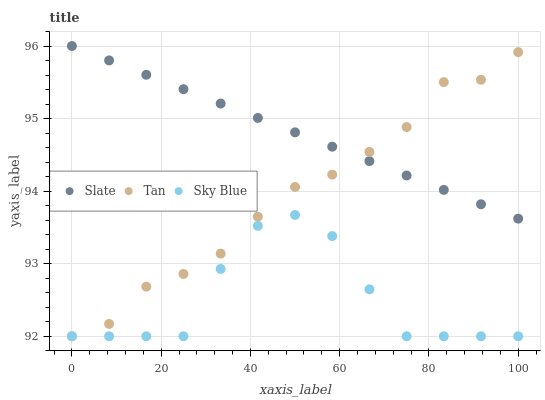Does Sky Blue have the minimum area under the curve?
Answer yes or no. Yes. Does Slate have the maximum area under the curve?
Answer yes or no. Yes. Does Tan have the minimum area under the curve?
Answer yes or no. No. Does Tan have the maximum area under the curve?
Answer yes or no. No. Is Slate the smoothest?
Answer yes or no. Yes. Is Sky Blue the roughest?
Answer yes or no. Yes. Is Tan the smoothest?
Answer yes or no. No. Is Tan the roughest?
Answer yes or no. No. Does Sky Blue have the lowest value?
Answer yes or no. Yes. Does Slate have the lowest value?
Answer yes or no. No. Does Slate have the highest value?
Answer yes or no. Yes. Does Tan have the highest value?
Answer yes or no. No. Is Sky Blue less than Slate?
Answer yes or no. Yes. Is Slate greater than Sky Blue?
Answer yes or no. Yes. Does Sky Blue intersect Tan?
Answer yes or no. Yes. Is Sky Blue less than Tan?
Answer yes or no. No. Is Sky Blue greater than Tan?
Answer yes or no. No. Does Sky Blue intersect Slate?
Answer yes or no. No. 